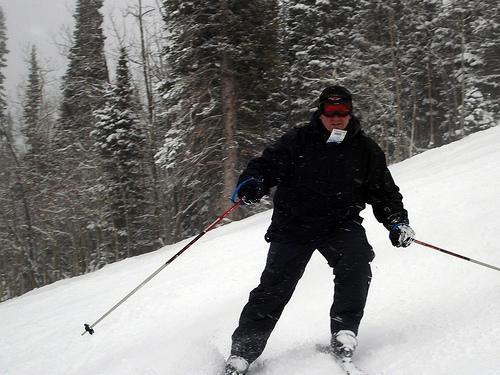How many people are shown?
Give a very brief answer. 1. 